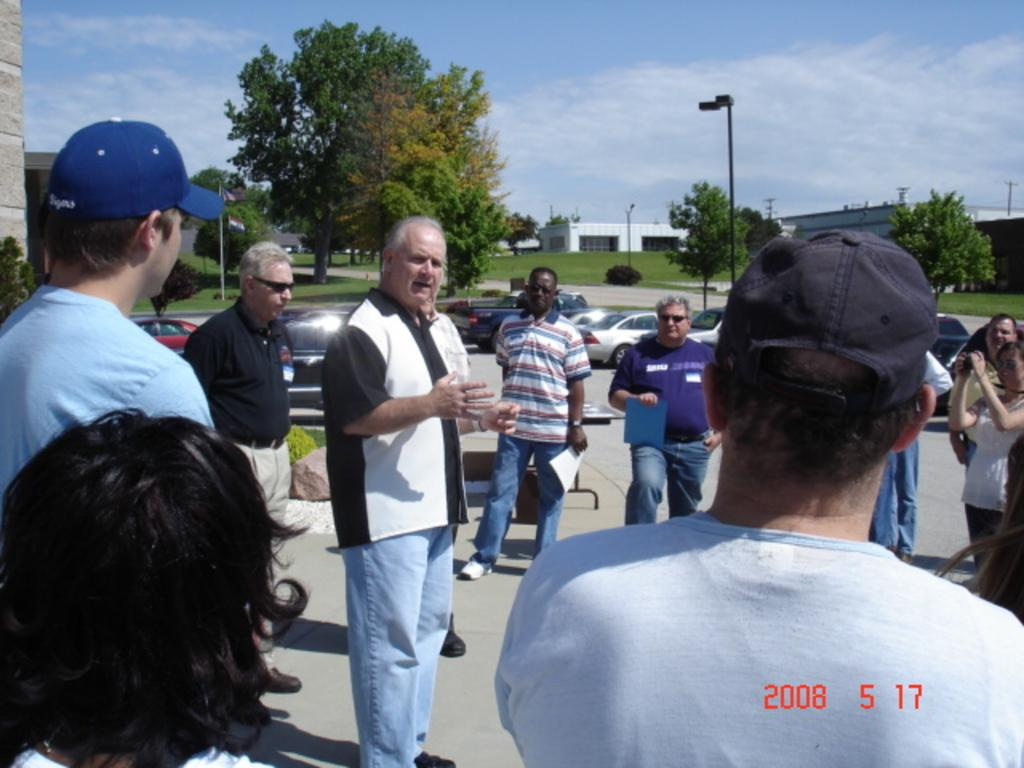What can be seen in the image involving people? There are people standing in the image. What else is present in the image besides people? There are vehicles and a light on a pole in the image. What can be seen in the background of the image? There are trees and the sky visible in the background of the image. What type of steel structure is present in the image? There is no steel structure present in the image. What angle is the light on the pole positioned at in the image? The angle of the light on the pole cannot be determined from the image. 